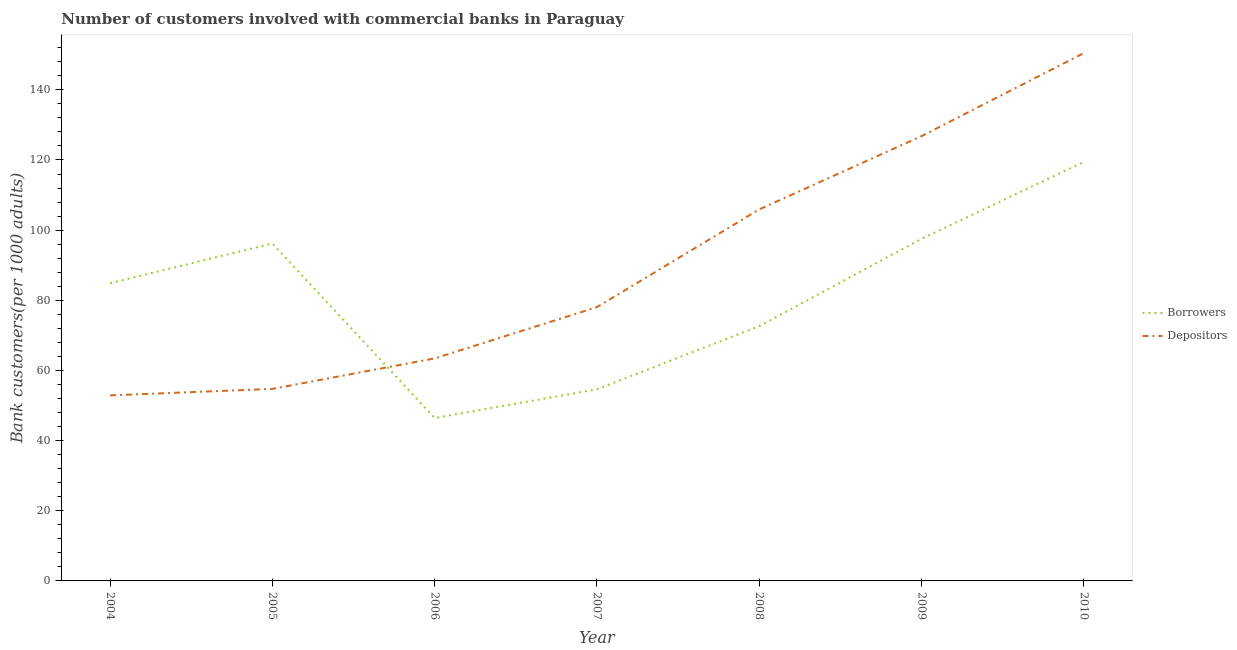Is the number of lines equal to the number of legend labels?
Provide a succinct answer. Yes. What is the number of depositors in 2010?
Your answer should be very brief. 150.47. Across all years, what is the maximum number of depositors?
Ensure brevity in your answer.  150.47. Across all years, what is the minimum number of depositors?
Your response must be concise. 52.9. What is the total number of depositors in the graph?
Make the answer very short. 632.31. What is the difference between the number of depositors in 2005 and that in 2007?
Your answer should be compact. -23.31. What is the difference between the number of borrowers in 2005 and the number of depositors in 2007?
Your response must be concise. 18.15. What is the average number of borrowers per year?
Your response must be concise. 81.68. In the year 2004, what is the difference between the number of borrowers and number of depositors?
Your response must be concise. 31.98. What is the ratio of the number of borrowers in 2005 to that in 2008?
Your answer should be compact. 1.32. Is the number of borrowers in 2005 less than that in 2006?
Give a very brief answer. No. Is the difference between the number of depositors in 2004 and 2009 greater than the difference between the number of borrowers in 2004 and 2009?
Provide a succinct answer. No. What is the difference between the highest and the second highest number of depositors?
Give a very brief answer. 23.67. What is the difference between the highest and the lowest number of borrowers?
Ensure brevity in your answer.  73.02. Is the sum of the number of borrowers in 2005 and 2007 greater than the maximum number of depositors across all years?
Make the answer very short. Yes. Does the number of depositors monotonically increase over the years?
Keep it short and to the point. Yes. Is the number of depositors strictly less than the number of borrowers over the years?
Ensure brevity in your answer.  No. How many lines are there?
Provide a short and direct response. 2. Are the values on the major ticks of Y-axis written in scientific E-notation?
Your answer should be very brief. No. Does the graph contain grids?
Your answer should be very brief. No. What is the title of the graph?
Keep it short and to the point. Number of customers involved with commercial banks in Paraguay. What is the label or title of the Y-axis?
Provide a short and direct response. Bank customers(per 1000 adults). What is the Bank customers(per 1000 adults) in Borrowers in 2004?
Offer a very short reply. 84.87. What is the Bank customers(per 1000 adults) in Depositors in 2004?
Offer a terse response. 52.9. What is the Bank customers(per 1000 adults) of Borrowers in 2005?
Offer a terse response. 96.2. What is the Bank customers(per 1000 adults) of Depositors in 2005?
Your response must be concise. 54.74. What is the Bank customers(per 1000 adults) in Borrowers in 2006?
Your answer should be very brief. 46.43. What is the Bank customers(per 1000 adults) of Depositors in 2006?
Keep it short and to the point. 63.43. What is the Bank customers(per 1000 adults) in Borrowers in 2007?
Offer a very short reply. 54.63. What is the Bank customers(per 1000 adults) of Depositors in 2007?
Make the answer very short. 78.05. What is the Bank customers(per 1000 adults) in Borrowers in 2008?
Ensure brevity in your answer.  72.63. What is the Bank customers(per 1000 adults) in Depositors in 2008?
Your answer should be compact. 105.92. What is the Bank customers(per 1000 adults) of Borrowers in 2009?
Ensure brevity in your answer.  97.54. What is the Bank customers(per 1000 adults) of Depositors in 2009?
Offer a very short reply. 126.8. What is the Bank customers(per 1000 adults) of Borrowers in 2010?
Make the answer very short. 119.45. What is the Bank customers(per 1000 adults) of Depositors in 2010?
Provide a succinct answer. 150.47. Across all years, what is the maximum Bank customers(per 1000 adults) in Borrowers?
Offer a very short reply. 119.45. Across all years, what is the maximum Bank customers(per 1000 adults) of Depositors?
Provide a succinct answer. 150.47. Across all years, what is the minimum Bank customers(per 1000 adults) of Borrowers?
Ensure brevity in your answer.  46.43. Across all years, what is the minimum Bank customers(per 1000 adults) in Depositors?
Keep it short and to the point. 52.9. What is the total Bank customers(per 1000 adults) in Borrowers in the graph?
Ensure brevity in your answer.  571.75. What is the total Bank customers(per 1000 adults) in Depositors in the graph?
Your response must be concise. 632.31. What is the difference between the Bank customers(per 1000 adults) in Borrowers in 2004 and that in 2005?
Ensure brevity in your answer.  -11.33. What is the difference between the Bank customers(per 1000 adults) of Depositors in 2004 and that in 2005?
Provide a succinct answer. -1.85. What is the difference between the Bank customers(per 1000 adults) of Borrowers in 2004 and that in 2006?
Offer a terse response. 38.44. What is the difference between the Bank customers(per 1000 adults) of Depositors in 2004 and that in 2006?
Offer a very short reply. -10.54. What is the difference between the Bank customers(per 1000 adults) in Borrowers in 2004 and that in 2007?
Your answer should be very brief. 30.24. What is the difference between the Bank customers(per 1000 adults) of Depositors in 2004 and that in 2007?
Offer a terse response. -25.15. What is the difference between the Bank customers(per 1000 adults) of Borrowers in 2004 and that in 2008?
Provide a succinct answer. 12.24. What is the difference between the Bank customers(per 1000 adults) in Depositors in 2004 and that in 2008?
Give a very brief answer. -53.02. What is the difference between the Bank customers(per 1000 adults) in Borrowers in 2004 and that in 2009?
Ensure brevity in your answer.  -12.66. What is the difference between the Bank customers(per 1000 adults) in Depositors in 2004 and that in 2009?
Provide a short and direct response. -73.9. What is the difference between the Bank customers(per 1000 adults) of Borrowers in 2004 and that in 2010?
Offer a terse response. -34.57. What is the difference between the Bank customers(per 1000 adults) of Depositors in 2004 and that in 2010?
Provide a short and direct response. -97.57. What is the difference between the Bank customers(per 1000 adults) of Borrowers in 2005 and that in 2006?
Keep it short and to the point. 49.77. What is the difference between the Bank customers(per 1000 adults) of Depositors in 2005 and that in 2006?
Keep it short and to the point. -8.69. What is the difference between the Bank customers(per 1000 adults) of Borrowers in 2005 and that in 2007?
Your answer should be very brief. 41.57. What is the difference between the Bank customers(per 1000 adults) in Depositors in 2005 and that in 2007?
Provide a succinct answer. -23.31. What is the difference between the Bank customers(per 1000 adults) in Borrowers in 2005 and that in 2008?
Your answer should be very brief. 23.57. What is the difference between the Bank customers(per 1000 adults) in Depositors in 2005 and that in 2008?
Provide a succinct answer. -51.17. What is the difference between the Bank customers(per 1000 adults) of Borrowers in 2005 and that in 2009?
Keep it short and to the point. -1.33. What is the difference between the Bank customers(per 1000 adults) in Depositors in 2005 and that in 2009?
Ensure brevity in your answer.  -72.05. What is the difference between the Bank customers(per 1000 adults) in Borrowers in 2005 and that in 2010?
Keep it short and to the point. -23.24. What is the difference between the Bank customers(per 1000 adults) in Depositors in 2005 and that in 2010?
Keep it short and to the point. -95.72. What is the difference between the Bank customers(per 1000 adults) in Borrowers in 2006 and that in 2007?
Give a very brief answer. -8.2. What is the difference between the Bank customers(per 1000 adults) of Depositors in 2006 and that in 2007?
Make the answer very short. -14.62. What is the difference between the Bank customers(per 1000 adults) in Borrowers in 2006 and that in 2008?
Your response must be concise. -26.2. What is the difference between the Bank customers(per 1000 adults) of Depositors in 2006 and that in 2008?
Keep it short and to the point. -42.48. What is the difference between the Bank customers(per 1000 adults) of Borrowers in 2006 and that in 2009?
Provide a succinct answer. -51.11. What is the difference between the Bank customers(per 1000 adults) in Depositors in 2006 and that in 2009?
Your answer should be very brief. -63.36. What is the difference between the Bank customers(per 1000 adults) in Borrowers in 2006 and that in 2010?
Your answer should be very brief. -73.02. What is the difference between the Bank customers(per 1000 adults) of Depositors in 2006 and that in 2010?
Ensure brevity in your answer.  -87.03. What is the difference between the Bank customers(per 1000 adults) of Borrowers in 2007 and that in 2008?
Your response must be concise. -18. What is the difference between the Bank customers(per 1000 adults) in Depositors in 2007 and that in 2008?
Make the answer very short. -27.87. What is the difference between the Bank customers(per 1000 adults) of Borrowers in 2007 and that in 2009?
Offer a very short reply. -42.91. What is the difference between the Bank customers(per 1000 adults) in Depositors in 2007 and that in 2009?
Give a very brief answer. -48.75. What is the difference between the Bank customers(per 1000 adults) of Borrowers in 2007 and that in 2010?
Your response must be concise. -64.81. What is the difference between the Bank customers(per 1000 adults) in Depositors in 2007 and that in 2010?
Provide a short and direct response. -72.42. What is the difference between the Bank customers(per 1000 adults) in Borrowers in 2008 and that in 2009?
Ensure brevity in your answer.  -24.9. What is the difference between the Bank customers(per 1000 adults) of Depositors in 2008 and that in 2009?
Offer a very short reply. -20.88. What is the difference between the Bank customers(per 1000 adults) in Borrowers in 2008 and that in 2010?
Your response must be concise. -46.81. What is the difference between the Bank customers(per 1000 adults) in Depositors in 2008 and that in 2010?
Make the answer very short. -44.55. What is the difference between the Bank customers(per 1000 adults) of Borrowers in 2009 and that in 2010?
Offer a very short reply. -21.91. What is the difference between the Bank customers(per 1000 adults) in Depositors in 2009 and that in 2010?
Keep it short and to the point. -23.67. What is the difference between the Bank customers(per 1000 adults) in Borrowers in 2004 and the Bank customers(per 1000 adults) in Depositors in 2005?
Your answer should be very brief. 30.13. What is the difference between the Bank customers(per 1000 adults) in Borrowers in 2004 and the Bank customers(per 1000 adults) in Depositors in 2006?
Keep it short and to the point. 21.44. What is the difference between the Bank customers(per 1000 adults) in Borrowers in 2004 and the Bank customers(per 1000 adults) in Depositors in 2007?
Provide a succinct answer. 6.82. What is the difference between the Bank customers(per 1000 adults) of Borrowers in 2004 and the Bank customers(per 1000 adults) of Depositors in 2008?
Give a very brief answer. -21.04. What is the difference between the Bank customers(per 1000 adults) of Borrowers in 2004 and the Bank customers(per 1000 adults) of Depositors in 2009?
Give a very brief answer. -41.92. What is the difference between the Bank customers(per 1000 adults) of Borrowers in 2004 and the Bank customers(per 1000 adults) of Depositors in 2010?
Provide a short and direct response. -65.59. What is the difference between the Bank customers(per 1000 adults) in Borrowers in 2005 and the Bank customers(per 1000 adults) in Depositors in 2006?
Provide a succinct answer. 32.77. What is the difference between the Bank customers(per 1000 adults) of Borrowers in 2005 and the Bank customers(per 1000 adults) of Depositors in 2007?
Make the answer very short. 18.15. What is the difference between the Bank customers(per 1000 adults) in Borrowers in 2005 and the Bank customers(per 1000 adults) in Depositors in 2008?
Your answer should be compact. -9.71. What is the difference between the Bank customers(per 1000 adults) of Borrowers in 2005 and the Bank customers(per 1000 adults) of Depositors in 2009?
Give a very brief answer. -30.59. What is the difference between the Bank customers(per 1000 adults) of Borrowers in 2005 and the Bank customers(per 1000 adults) of Depositors in 2010?
Keep it short and to the point. -54.26. What is the difference between the Bank customers(per 1000 adults) of Borrowers in 2006 and the Bank customers(per 1000 adults) of Depositors in 2007?
Offer a terse response. -31.62. What is the difference between the Bank customers(per 1000 adults) in Borrowers in 2006 and the Bank customers(per 1000 adults) in Depositors in 2008?
Make the answer very short. -59.49. What is the difference between the Bank customers(per 1000 adults) in Borrowers in 2006 and the Bank customers(per 1000 adults) in Depositors in 2009?
Ensure brevity in your answer.  -80.37. What is the difference between the Bank customers(per 1000 adults) of Borrowers in 2006 and the Bank customers(per 1000 adults) of Depositors in 2010?
Keep it short and to the point. -104.04. What is the difference between the Bank customers(per 1000 adults) of Borrowers in 2007 and the Bank customers(per 1000 adults) of Depositors in 2008?
Provide a succinct answer. -51.29. What is the difference between the Bank customers(per 1000 adults) of Borrowers in 2007 and the Bank customers(per 1000 adults) of Depositors in 2009?
Provide a short and direct response. -72.17. What is the difference between the Bank customers(per 1000 adults) of Borrowers in 2007 and the Bank customers(per 1000 adults) of Depositors in 2010?
Your answer should be compact. -95.84. What is the difference between the Bank customers(per 1000 adults) of Borrowers in 2008 and the Bank customers(per 1000 adults) of Depositors in 2009?
Offer a very short reply. -54.16. What is the difference between the Bank customers(per 1000 adults) in Borrowers in 2008 and the Bank customers(per 1000 adults) in Depositors in 2010?
Your response must be concise. -77.83. What is the difference between the Bank customers(per 1000 adults) in Borrowers in 2009 and the Bank customers(per 1000 adults) in Depositors in 2010?
Ensure brevity in your answer.  -52.93. What is the average Bank customers(per 1000 adults) in Borrowers per year?
Your response must be concise. 81.68. What is the average Bank customers(per 1000 adults) in Depositors per year?
Offer a terse response. 90.33. In the year 2004, what is the difference between the Bank customers(per 1000 adults) of Borrowers and Bank customers(per 1000 adults) of Depositors?
Provide a succinct answer. 31.98. In the year 2005, what is the difference between the Bank customers(per 1000 adults) of Borrowers and Bank customers(per 1000 adults) of Depositors?
Offer a very short reply. 41.46. In the year 2006, what is the difference between the Bank customers(per 1000 adults) in Borrowers and Bank customers(per 1000 adults) in Depositors?
Offer a terse response. -17. In the year 2007, what is the difference between the Bank customers(per 1000 adults) of Borrowers and Bank customers(per 1000 adults) of Depositors?
Provide a short and direct response. -23.42. In the year 2008, what is the difference between the Bank customers(per 1000 adults) in Borrowers and Bank customers(per 1000 adults) in Depositors?
Your response must be concise. -33.28. In the year 2009, what is the difference between the Bank customers(per 1000 adults) of Borrowers and Bank customers(per 1000 adults) of Depositors?
Ensure brevity in your answer.  -29.26. In the year 2010, what is the difference between the Bank customers(per 1000 adults) of Borrowers and Bank customers(per 1000 adults) of Depositors?
Make the answer very short. -31.02. What is the ratio of the Bank customers(per 1000 adults) in Borrowers in 2004 to that in 2005?
Make the answer very short. 0.88. What is the ratio of the Bank customers(per 1000 adults) of Depositors in 2004 to that in 2005?
Provide a succinct answer. 0.97. What is the ratio of the Bank customers(per 1000 adults) in Borrowers in 2004 to that in 2006?
Give a very brief answer. 1.83. What is the ratio of the Bank customers(per 1000 adults) in Depositors in 2004 to that in 2006?
Offer a terse response. 0.83. What is the ratio of the Bank customers(per 1000 adults) in Borrowers in 2004 to that in 2007?
Offer a terse response. 1.55. What is the ratio of the Bank customers(per 1000 adults) in Depositors in 2004 to that in 2007?
Make the answer very short. 0.68. What is the ratio of the Bank customers(per 1000 adults) in Borrowers in 2004 to that in 2008?
Your answer should be compact. 1.17. What is the ratio of the Bank customers(per 1000 adults) in Depositors in 2004 to that in 2008?
Offer a very short reply. 0.5. What is the ratio of the Bank customers(per 1000 adults) of Borrowers in 2004 to that in 2009?
Provide a short and direct response. 0.87. What is the ratio of the Bank customers(per 1000 adults) in Depositors in 2004 to that in 2009?
Offer a very short reply. 0.42. What is the ratio of the Bank customers(per 1000 adults) in Borrowers in 2004 to that in 2010?
Provide a short and direct response. 0.71. What is the ratio of the Bank customers(per 1000 adults) in Depositors in 2004 to that in 2010?
Provide a succinct answer. 0.35. What is the ratio of the Bank customers(per 1000 adults) of Borrowers in 2005 to that in 2006?
Make the answer very short. 2.07. What is the ratio of the Bank customers(per 1000 adults) of Depositors in 2005 to that in 2006?
Offer a very short reply. 0.86. What is the ratio of the Bank customers(per 1000 adults) in Borrowers in 2005 to that in 2007?
Your answer should be very brief. 1.76. What is the ratio of the Bank customers(per 1000 adults) in Depositors in 2005 to that in 2007?
Provide a short and direct response. 0.7. What is the ratio of the Bank customers(per 1000 adults) of Borrowers in 2005 to that in 2008?
Provide a short and direct response. 1.32. What is the ratio of the Bank customers(per 1000 adults) in Depositors in 2005 to that in 2008?
Make the answer very short. 0.52. What is the ratio of the Bank customers(per 1000 adults) in Borrowers in 2005 to that in 2009?
Offer a very short reply. 0.99. What is the ratio of the Bank customers(per 1000 adults) of Depositors in 2005 to that in 2009?
Your answer should be compact. 0.43. What is the ratio of the Bank customers(per 1000 adults) in Borrowers in 2005 to that in 2010?
Your answer should be very brief. 0.81. What is the ratio of the Bank customers(per 1000 adults) of Depositors in 2005 to that in 2010?
Your answer should be very brief. 0.36. What is the ratio of the Bank customers(per 1000 adults) in Borrowers in 2006 to that in 2007?
Give a very brief answer. 0.85. What is the ratio of the Bank customers(per 1000 adults) of Depositors in 2006 to that in 2007?
Ensure brevity in your answer.  0.81. What is the ratio of the Bank customers(per 1000 adults) of Borrowers in 2006 to that in 2008?
Provide a succinct answer. 0.64. What is the ratio of the Bank customers(per 1000 adults) of Depositors in 2006 to that in 2008?
Keep it short and to the point. 0.6. What is the ratio of the Bank customers(per 1000 adults) of Borrowers in 2006 to that in 2009?
Give a very brief answer. 0.48. What is the ratio of the Bank customers(per 1000 adults) in Depositors in 2006 to that in 2009?
Your response must be concise. 0.5. What is the ratio of the Bank customers(per 1000 adults) of Borrowers in 2006 to that in 2010?
Your answer should be very brief. 0.39. What is the ratio of the Bank customers(per 1000 adults) in Depositors in 2006 to that in 2010?
Provide a succinct answer. 0.42. What is the ratio of the Bank customers(per 1000 adults) of Borrowers in 2007 to that in 2008?
Ensure brevity in your answer.  0.75. What is the ratio of the Bank customers(per 1000 adults) in Depositors in 2007 to that in 2008?
Your answer should be compact. 0.74. What is the ratio of the Bank customers(per 1000 adults) in Borrowers in 2007 to that in 2009?
Offer a very short reply. 0.56. What is the ratio of the Bank customers(per 1000 adults) of Depositors in 2007 to that in 2009?
Provide a succinct answer. 0.62. What is the ratio of the Bank customers(per 1000 adults) of Borrowers in 2007 to that in 2010?
Your answer should be very brief. 0.46. What is the ratio of the Bank customers(per 1000 adults) of Depositors in 2007 to that in 2010?
Make the answer very short. 0.52. What is the ratio of the Bank customers(per 1000 adults) in Borrowers in 2008 to that in 2009?
Give a very brief answer. 0.74. What is the ratio of the Bank customers(per 1000 adults) of Depositors in 2008 to that in 2009?
Your answer should be very brief. 0.84. What is the ratio of the Bank customers(per 1000 adults) in Borrowers in 2008 to that in 2010?
Provide a short and direct response. 0.61. What is the ratio of the Bank customers(per 1000 adults) of Depositors in 2008 to that in 2010?
Offer a very short reply. 0.7. What is the ratio of the Bank customers(per 1000 adults) in Borrowers in 2009 to that in 2010?
Offer a very short reply. 0.82. What is the ratio of the Bank customers(per 1000 adults) in Depositors in 2009 to that in 2010?
Offer a very short reply. 0.84. What is the difference between the highest and the second highest Bank customers(per 1000 adults) of Borrowers?
Keep it short and to the point. 21.91. What is the difference between the highest and the second highest Bank customers(per 1000 adults) in Depositors?
Your response must be concise. 23.67. What is the difference between the highest and the lowest Bank customers(per 1000 adults) in Borrowers?
Offer a terse response. 73.02. What is the difference between the highest and the lowest Bank customers(per 1000 adults) in Depositors?
Your answer should be very brief. 97.57. 